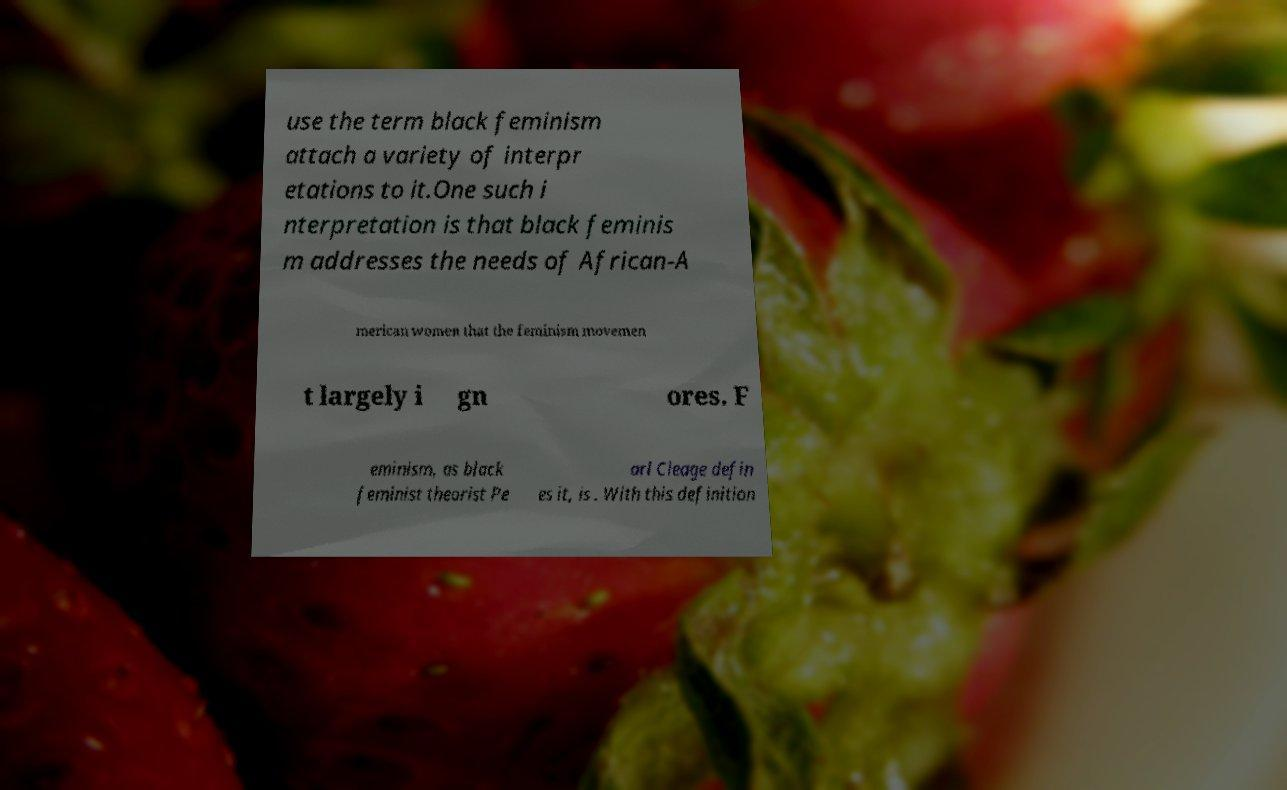Could you extract and type out the text from this image? use the term black feminism attach a variety of interpr etations to it.One such i nterpretation is that black feminis m addresses the needs of African-A merican women that the feminism movemen t largely i gn ores. F eminism, as black feminist theorist Pe arl Cleage defin es it, is . With this definition 